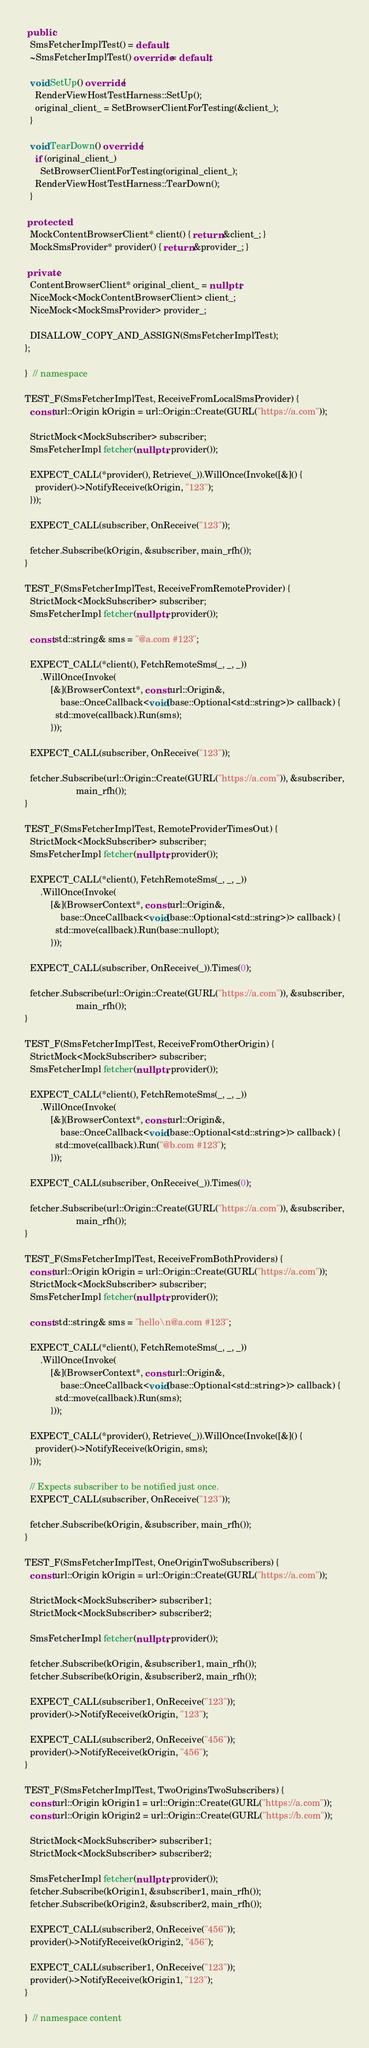<code> <loc_0><loc_0><loc_500><loc_500><_C++_> public:
  SmsFetcherImplTest() = default;
  ~SmsFetcherImplTest() override = default;

  void SetUp() override {
    RenderViewHostTestHarness::SetUp();
    original_client_ = SetBrowserClientForTesting(&client_);
  }

  void TearDown() override {
    if (original_client_)
      SetBrowserClientForTesting(original_client_);
    RenderViewHostTestHarness::TearDown();
  }

 protected:
  MockContentBrowserClient* client() { return &client_; }
  MockSmsProvider* provider() { return &provider_; }

 private:
  ContentBrowserClient* original_client_ = nullptr;
  NiceMock<MockContentBrowserClient> client_;
  NiceMock<MockSmsProvider> provider_;

  DISALLOW_COPY_AND_ASSIGN(SmsFetcherImplTest);
};

}  // namespace

TEST_F(SmsFetcherImplTest, ReceiveFromLocalSmsProvider) {
  const url::Origin kOrigin = url::Origin::Create(GURL("https://a.com"));

  StrictMock<MockSubscriber> subscriber;
  SmsFetcherImpl fetcher(nullptr, provider());

  EXPECT_CALL(*provider(), Retrieve(_)).WillOnce(Invoke([&]() {
    provider()->NotifyReceive(kOrigin, "123");
  }));

  EXPECT_CALL(subscriber, OnReceive("123"));

  fetcher.Subscribe(kOrigin, &subscriber, main_rfh());
}

TEST_F(SmsFetcherImplTest, ReceiveFromRemoteProvider) {
  StrictMock<MockSubscriber> subscriber;
  SmsFetcherImpl fetcher(nullptr, provider());

  const std::string& sms = "@a.com #123";

  EXPECT_CALL(*client(), FetchRemoteSms(_, _, _))
      .WillOnce(Invoke(
          [&](BrowserContext*, const url::Origin&,
              base::OnceCallback<void(base::Optional<std::string>)> callback) {
            std::move(callback).Run(sms);
          }));

  EXPECT_CALL(subscriber, OnReceive("123"));

  fetcher.Subscribe(url::Origin::Create(GURL("https://a.com")), &subscriber,
                    main_rfh());
}

TEST_F(SmsFetcherImplTest, RemoteProviderTimesOut) {
  StrictMock<MockSubscriber> subscriber;
  SmsFetcherImpl fetcher(nullptr, provider());

  EXPECT_CALL(*client(), FetchRemoteSms(_, _, _))
      .WillOnce(Invoke(
          [&](BrowserContext*, const url::Origin&,
              base::OnceCallback<void(base::Optional<std::string>)> callback) {
            std::move(callback).Run(base::nullopt);
          }));

  EXPECT_CALL(subscriber, OnReceive(_)).Times(0);

  fetcher.Subscribe(url::Origin::Create(GURL("https://a.com")), &subscriber,
                    main_rfh());
}

TEST_F(SmsFetcherImplTest, ReceiveFromOtherOrigin) {
  StrictMock<MockSubscriber> subscriber;
  SmsFetcherImpl fetcher(nullptr, provider());

  EXPECT_CALL(*client(), FetchRemoteSms(_, _, _))
      .WillOnce(Invoke(
          [&](BrowserContext*, const url::Origin&,
              base::OnceCallback<void(base::Optional<std::string>)> callback) {
            std::move(callback).Run("@b.com #123");
          }));

  EXPECT_CALL(subscriber, OnReceive(_)).Times(0);

  fetcher.Subscribe(url::Origin::Create(GURL("https://a.com")), &subscriber,
                    main_rfh());
}

TEST_F(SmsFetcherImplTest, ReceiveFromBothProviders) {
  const url::Origin kOrigin = url::Origin::Create(GURL("https://a.com"));
  StrictMock<MockSubscriber> subscriber;
  SmsFetcherImpl fetcher(nullptr, provider());

  const std::string& sms = "hello\n@a.com #123";

  EXPECT_CALL(*client(), FetchRemoteSms(_, _, _))
      .WillOnce(Invoke(
          [&](BrowserContext*, const url::Origin&,
              base::OnceCallback<void(base::Optional<std::string>)> callback) {
            std::move(callback).Run(sms);
          }));

  EXPECT_CALL(*provider(), Retrieve(_)).WillOnce(Invoke([&]() {
    provider()->NotifyReceive(kOrigin, sms);
  }));

  // Expects subscriber to be notified just once.
  EXPECT_CALL(subscriber, OnReceive("123"));

  fetcher.Subscribe(kOrigin, &subscriber, main_rfh());
}

TEST_F(SmsFetcherImplTest, OneOriginTwoSubscribers) {
  const url::Origin kOrigin = url::Origin::Create(GURL("https://a.com"));

  StrictMock<MockSubscriber> subscriber1;
  StrictMock<MockSubscriber> subscriber2;

  SmsFetcherImpl fetcher(nullptr, provider());

  fetcher.Subscribe(kOrigin, &subscriber1, main_rfh());
  fetcher.Subscribe(kOrigin, &subscriber2, main_rfh());

  EXPECT_CALL(subscriber1, OnReceive("123"));
  provider()->NotifyReceive(kOrigin, "123");

  EXPECT_CALL(subscriber2, OnReceive("456"));
  provider()->NotifyReceive(kOrigin, "456");
}

TEST_F(SmsFetcherImplTest, TwoOriginsTwoSubscribers) {
  const url::Origin kOrigin1 = url::Origin::Create(GURL("https://a.com"));
  const url::Origin kOrigin2 = url::Origin::Create(GURL("https://b.com"));

  StrictMock<MockSubscriber> subscriber1;
  StrictMock<MockSubscriber> subscriber2;

  SmsFetcherImpl fetcher(nullptr, provider());
  fetcher.Subscribe(kOrigin1, &subscriber1, main_rfh());
  fetcher.Subscribe(kOrigin2, &subscriber2, main_rfh());

  EXPECT_CALL(subscriber2, OnReceive("456"));
  provider()->NotifyReceive(kOrigin2, "456");

  EXPECT_CALL(subscriber1, OnReceive("123"));
  provider()->NotifyReceive(kOrigin1, "123");
}

}  // namespace content
</code> 